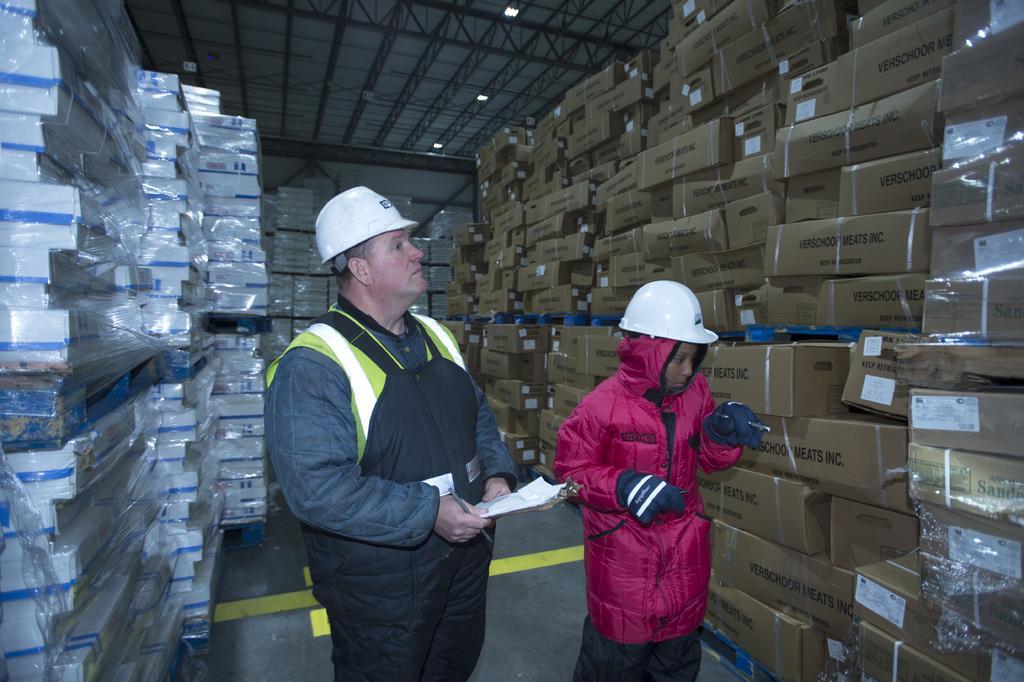How would you summarize this image in a sentence or two? In front of the picture, we see a man and the women are standing. Both of them are wearing the white helmets. We see the man is holding a paper and a pen in his hands. On the right side, we see many carton boxes. On the left side, we see the boxes in white and blue color. In the background, we see white color boxes. At the top, we see the roof of the shed. This picture might be clicked in the storage godown. 